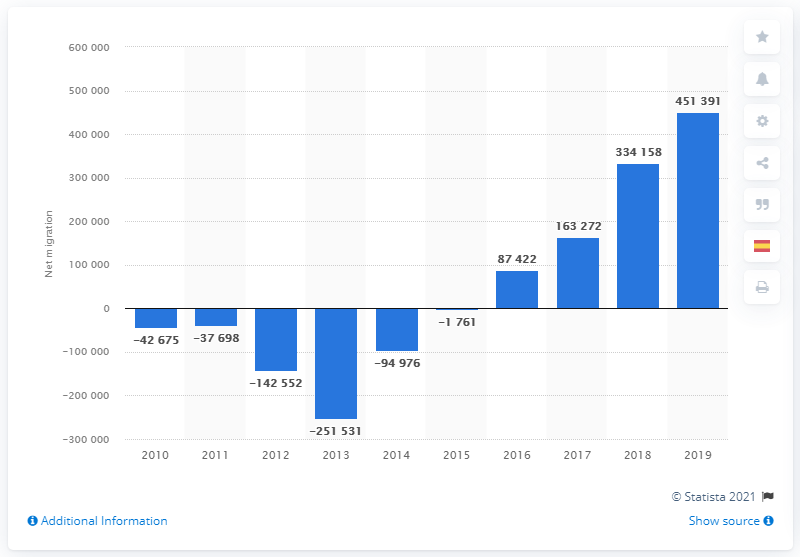Specify some key components in this picture. In 2016, more people immigrated to Spain than emigrated from the country. In 2018, the net migration balance of Spain with other countries was 451,391. 